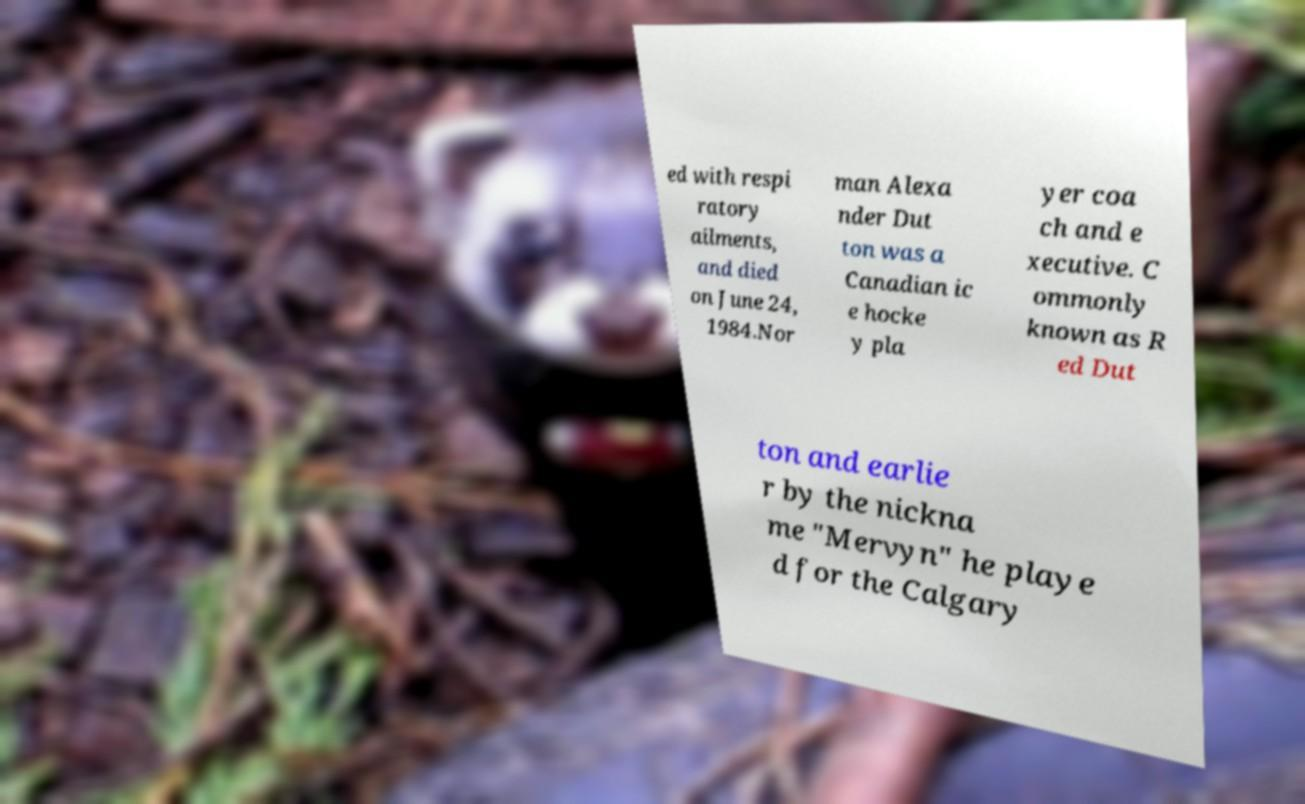What messages or text are displayed in this image? I need them in a readable, typed format. ed with respi ratory ailments, and died on June 24, 1984.Nor man Alexa nder Dut ton was a Canadian ic e hocke y pla yer coa ch and e xecutive. C ommonly known as R ed Dut ton and earlie r by the nickna me "Mervyn" he playe d for the Calgary 